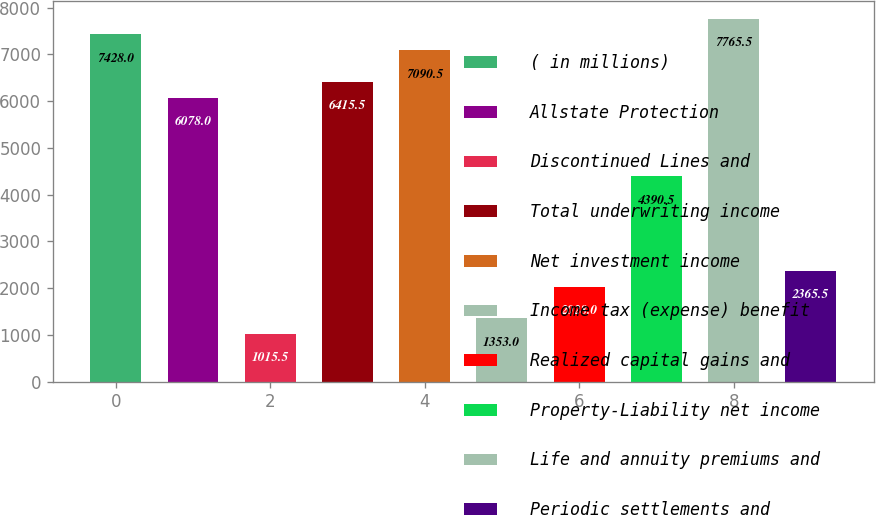Convert chart to OTSL. <chart><loc_0><loc_0><loc_500><loc_500><bar_chart><fcel>( in millions)<fcel>Allstate Protection<fcel>Discontinued Lines and<fcel>Total underwriting income<fcel>Net investment income<fcel>Income tax (expense) benefit<fcel>Realized capital gains and<fcel>Property-Liability net income<fcel>Life and annuity premiums and<fcel>Periodic settlements and<nl><fcel>7428<fcel>6078<fcel>1015.5<fcel>6415.5<fcel>7090.5<fcel>1353<fcel>2028<fcel>4390.5<fcel>7765.5<fcel>2365.5<nl></chart> 